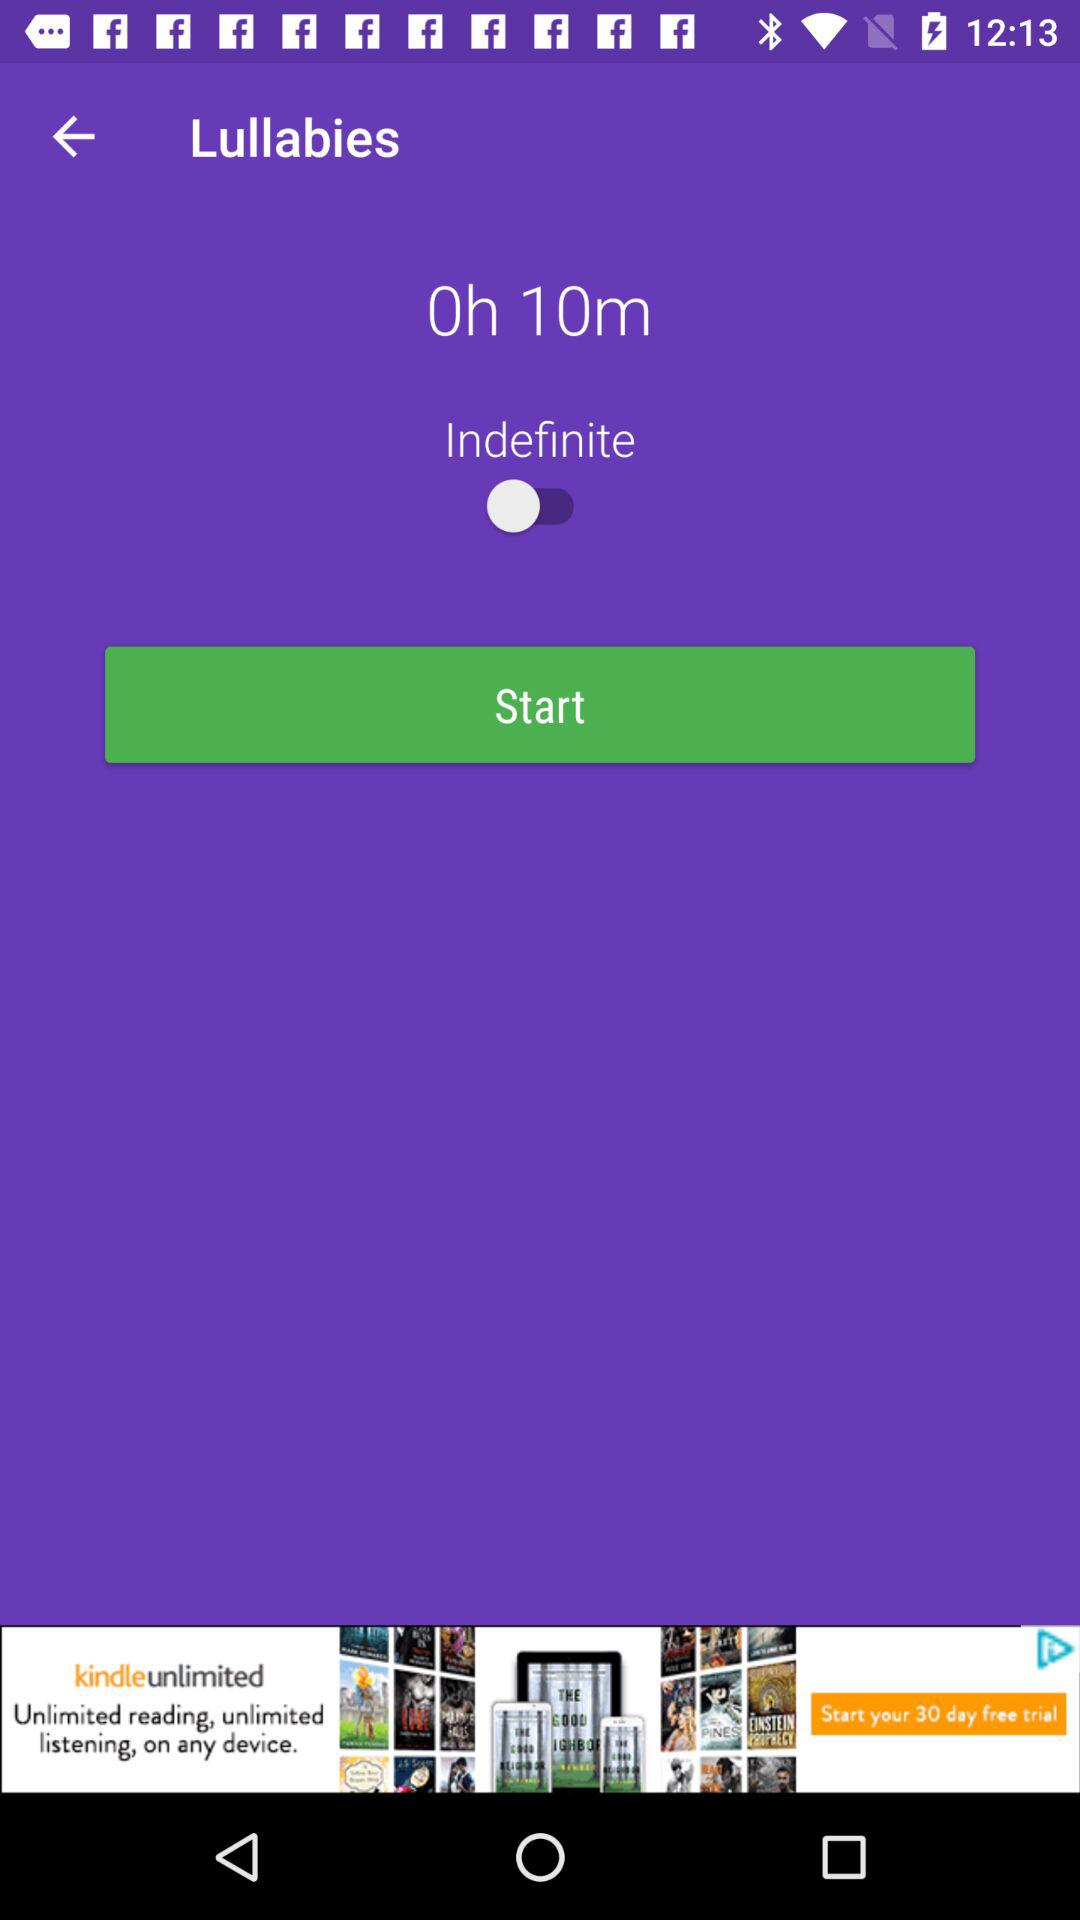What is the version of this application?
When the provided information is insufficient, respond with <no answer>. <no answer> 